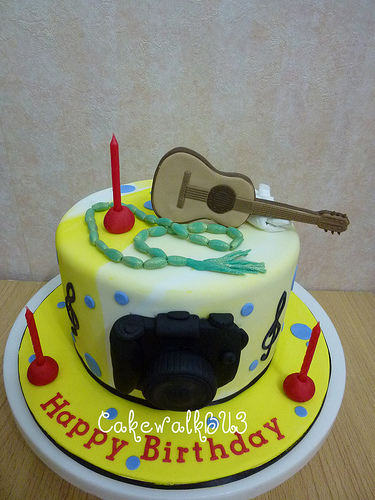<image>
Is there a guitar on the cake? Yes. Looking at the image, I can see the guitar is positioned on top of the cake, with the cake providing support. Where is the beads in relation to the cake? Is it on the cake? Yes. Looking at the image, I can see the beads is positioned on top of the cake, with the cake providing support. Is there a trumpet on the book? No. The trumpet is not positioned on the book. They may be near each other, but the trumpet is not supported by or resting on top of the book. Is there a cake next to the wall? Yes. The cake is positioned adjacent to the wall, located nearby in the same general area. 